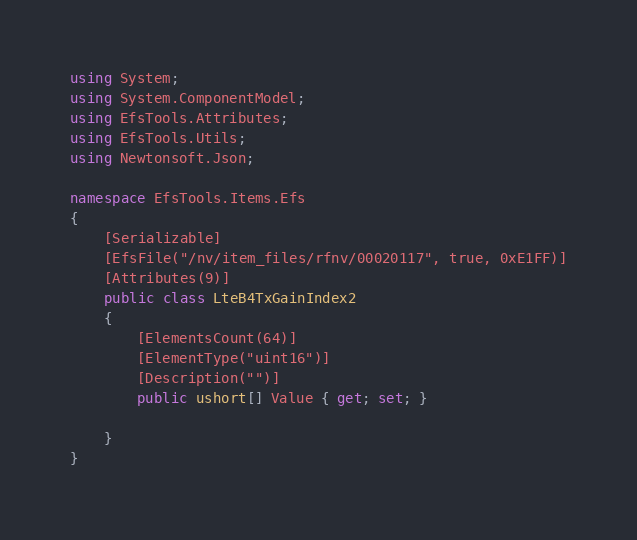Convert code to text. <code><loc_0><loc_0><loc_500><loc_500><_C#_>using System;
using System.ComponentModel;
using EfsTools.Attributes;
using EfsTools.Utils;
using Newtonsoft.Json;

namespace EfsTools.Items.Efs
{
    [Serializable]
    [EfsFile("/nv/item_files/rfnv/00020117", true, 0xE1FF)]
    [Attributes(9)]
    public class LteB4TxGainIndex2
    {
        [ElementsCount(64)]
        [ElementType("uint16")]
        [Description("")]
        public ushort[] Value { get; set; }
        
    }
}
</code> 